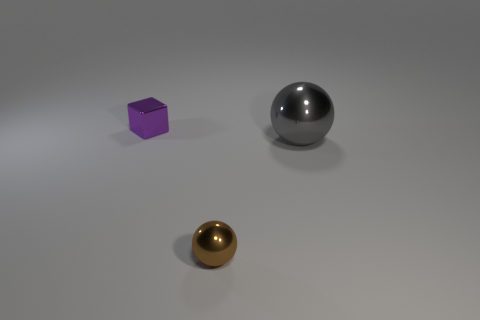Add 2 small yellow shiny cylinders. How many objects exist? 5 Subtract all spheres. How many objects are left? 1 Add 3 small red objects. How many small red objects exist? 3 Subtract 0 red blocks. How many objects are left? 3 Subtract 2 balls. How many balls are left? 0 Subtract all yellow spheres. Subtract all red blocks. How many spheres are left? 2 Subtract all cyan cylinders. How many brown spheres are left? 1 Subtract all large shiny things. Subtract all gray objects. How many objects are left? 1 Add 3 tiny metal cubes. How many tiny metal cubes are left? 4 